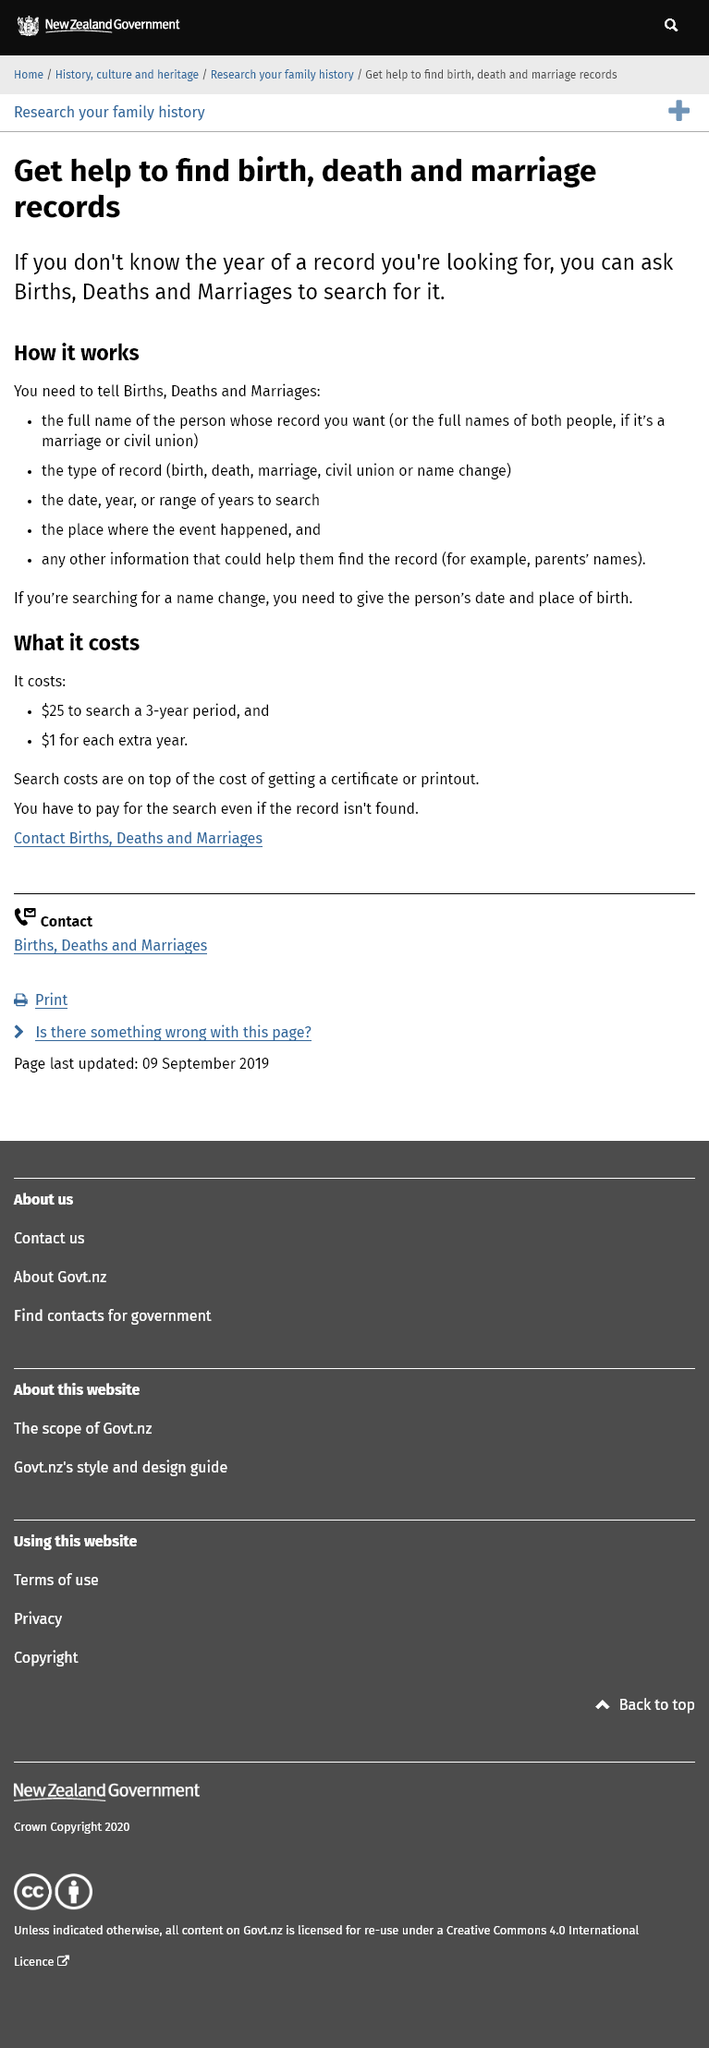Give some essential details in this illustration. The cost of searching for records is $25 for a 3-year period and $1 for each additional year. The New Jersey Department of Health offers the ability to search for records related to births, deaths, marriages, civil unions, and name changes. Even if no records are found, you still have to pay for the search. 